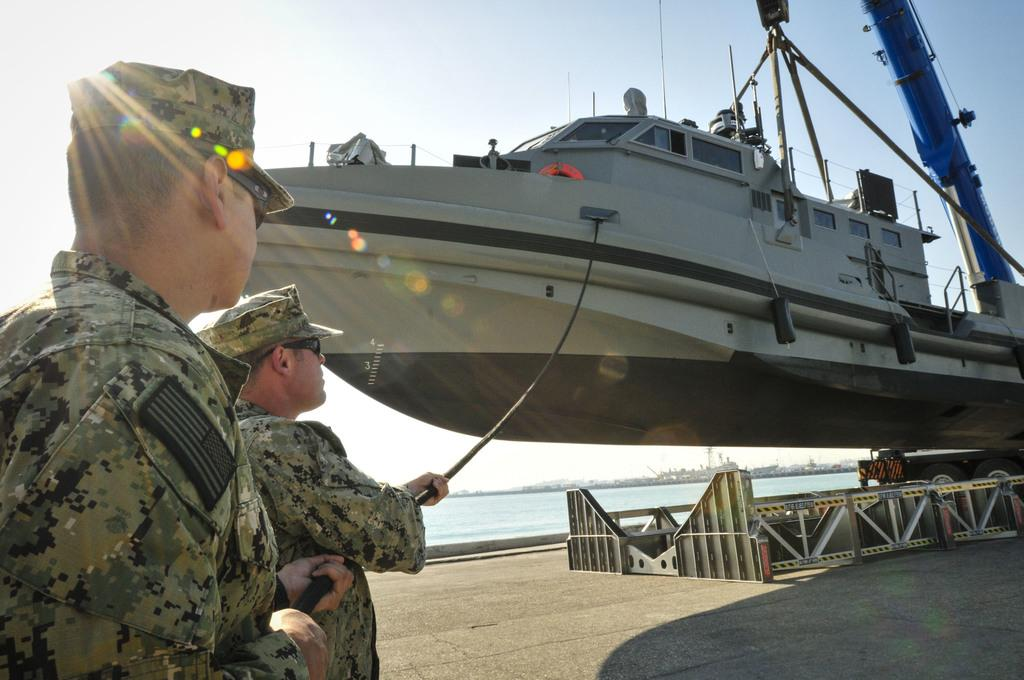How many men are in the image? There are two men in the image. What are the men wearing on their heads? The men are wearing caps. What are the men wearing to protect their eyes? The men are wearing goggles. Where are the men standing in the image? The men are standing on the ground. What can be seen in the image besides the men? There is a ship, water, and the sky visible in the image. What type of pigs can be seen swinging on the ship in the image? There are no pigs or swings present in the image; it features two men wearing caps and goggles, standing on the ground, with a ship, water, and sky visible in the background. 